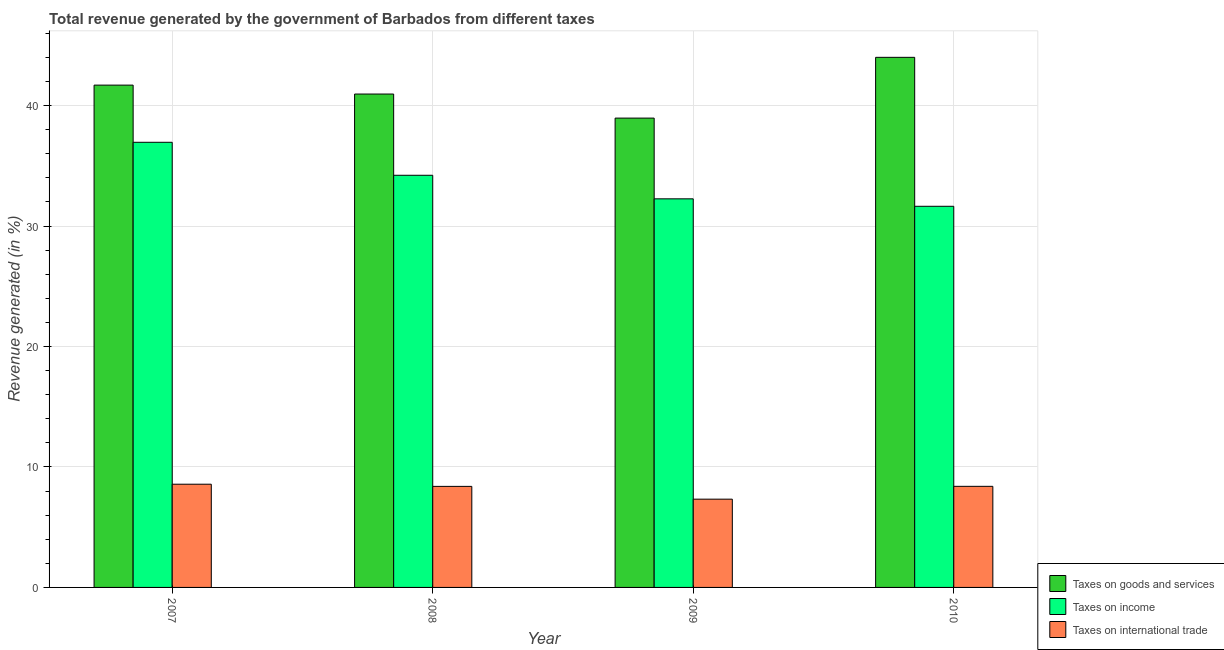How many different coloured bars are there?
Keep it short and to the point. 3. Are the number of bars per tick equal to the number of legend labels?
Provide a short and direct response. Yes. What is the label of the 3rd group of bars from the left?
Ensure brevity in your answer.  2009. In how many cases, is the number of bars for a given year not equal to the number of legend labels?
Provide a short and direct response. 0. What is the percentage of revenue generated by tax on international trade in 2008?
Your response must be concise. 8.39. Across all years, what is the maximum percentage of revenue generated by taxes on income?
Ensure brevity in your answer.  36.96. Across all years, what is the minimum percentage of revenue generated by taxes on income?
Your answer should be compact. 31.64. What is the total percentage of revenue generated by taxes on income in the graph?
Ensure brevity in your answer.  135.08. What is the difference between the percentage of revenue generated by taxes on income in 2007 and that in 2010?
Ensure brevity in your answer.  5.31. What is the difference between the percentage of revenue generated by taxes on income in 2010 and the percentage of revenue generated by tax on international trade in 2008?
Provide a short and direct response. -2.58. What is the average percentage of revenue generated by taxes on goods and services per year?
Keep it short and to the point. 41.41. In how many years, is the percentage of revenue generated by taxes on income greater than 14 %?
Provide a succinct answer. 4. What is the ratio of the percentage of revenue generated by taxes on goods and services in 2008 to that in 2009?
Make the answer very short. 1.05. Is the percentage of revenue generated by taxes on income in 2007 less than that in 2009?
Give a very brief answer. No. Is the difference between the percentage of revenue generated by taxes on income in 2008 and 2009 greater than the difference between the percentage of revenue generated by taxes on goods and services in 2008 and 2009?
Make the answer very short. No. What is the difference between the highest and the second highest percentage of revenue generated by taxes on income?
Offer a very short reply. 2.74. What is the difference between the highest and the lowest percentage of revenue generated by tax on international trade?
Your answer should be compact. 1.24. What does the 1st bar from the left in 2007 represents?
Provide a short and direct response. Taxes on goods and services. What does the 3rd bar from the right in 2009 represents?
Your answer should be compact. Taxes on goods and services. How many bars are there?
Your answer should be compact. 12. Are all the bars in the graph horizontal?
Make the answer very short. No. Does the graph contain any zero values?
Offer a terse response. No. Does the graph contain grids?
Keep it short and to the point. Yes. How are the legend labels stacked?
Make the answer very short. Vertical. What is the title of the graph?
Give a very brief answer. Total revenue generated by the government of Barbados from different taxes. What is the label or title of the X-axis?
Your response must be concise. Year. What is the label or title of the Y-axis?
Provide a short and direct response. Revenue generated (in %). What is the Revenue generated (in %) of Taxes on goods and services in 2007?
Offer a terse response. 41.7. What is the Revenue generated (in %) in Taxes on income in 2007?
Your response must be concise. 36.96. What is the Revenue generated (in %) in Taxes on international trade in 2007?
Offer a terse response. 8.57. What is the Revenue generated (in %) in Taxes on goods and services in 2008?
Provide a succinct answer. 40.96. What is the Revenue generated (in %) in Taxes on income in 2008?
Ensure brevity in your answer.  34.22. What is the Revenue generated (in %) in Taxes on international trade in 2008?
Your answer should be very brief. 8.39. What is the Revenue generated (in %) in Taxes on goods and services in 2009?
Ensure brevity in your answer.  38.97. What is the Revenue generated (in %) of Taxes on income in 2009?
Ensure brevity in your answer.  32.26. What is the Revenue generated (in %) of Taxes on international trade in 2009?
Make the answer very short. 7.33. What is the Revenue generated (in %) in Taxes on goods and services in 2010?
Your response must be concise. 44.01. What is the Revenue generated (in %) in Taxes on income in 2010?
Keep it short and to the point. 31.64. What is the Revenue generated (in %) of Taxes on international trade in 2010?
Provide a succinct answer. 8.39. Across all years, what is the maximum Revenue generated (in %) in Taxes on goods and services?
Provide a short and direct response. 44.01. Across all years, what is the maximum Revenue generated (in %) of Taxes on income?
Ensure brevity in your answer.  36.96. Across all years, what is the maximum Revenue generated (in %) of Taxes on international trade?
Provide a short and direct response. 8.57. Across all years, what is the minimum Revenue generated (in %) of Taxes on goods and services?
Make the answer very short. 38.97. Across all years, what is the minimum Revenue generated (in %) of Taxes on income?
Make the answer very short. 31.64. Across all years, what is the minimum Revenue generated (in %) of Taxes on international trade?
Your response must be concise. 7.33. What is the total Revenue generated (in %) in Taxes on goods and services in the graph?
Give a very brief answer. 165.64. What is the total Revenue generated (in %) in Taxes on income in the graph?
Give a very brief answer. 135.08. What is the total Revenue generated (in %) of Taxes on international trade in the graph?
Ensure brevity in your answer.  32.68. What is the difference between the Revenue generated (in %) in Taxes on goods and services in 2007 and that in 2008?
Offer a terse response. 0.74. What is the difference between the Revenue generated (in %) in Taxes on income in 2007 and that in 2008?
Ensure brevity in your answer.  2.74. What is the difference between the Revenue generated (in %) of Taxes on international trade in 2007 and that in 2008?
Your answer should be very brief. 0.18. What is the difference between the Revenue generated (in %) in Taxes on goods and services in 2007 and that in 2009?
Your answer should be compact. 2.74. What is the difference between the Revenue generated (in %) in Taxes on income in 2007 and that in 2009?
Give a very brief answer. 4.69. What is the difference between the Revenue generated (in %) of Taxes on international trade in 2007 and that in 2009?
Provide a short and direct response. 1.24. What is the difference between the Revenue generated (in %) in Taxes on goods and services in 2007 and that in 2010?
Offer a very short reply. -2.31. What is the difference between the Revenue generated (in %) in Taxes on income in 2007 and that in 2010?
Give a very brief answer. 5.31. What is the difference between the Revenue generated (in %) of Taxes on international trade in 2007 and that in 2010?
Make the answer very short. 0.18. What is the difference between the Revenue generated (in %) in Taxes on goods and services in 2008 and that in 2009?
Provide a succinct answer. 2. What is the difference between the Revenue generated (in %) in Taxes on income in 2008 and that in 2009?
Your answer should be compact. 1.96. What is the difference between the Revenue generated (in %) of Taxes on international trade in 2008 and that in 2009?
Make the answer very short. 1.06. What is the difference between the Revenue generated (in %) of Taxes on goods and services in 2008 and that in 2010?
Keep it short and to the point. -3.05. What is the difference between the Revenue generated (in %) in Taxes on income in 2008 and that in 2010?
Provide a short and direct response. 2.58. What is the difference between the Revenue generated (in %) of Taxes on international trade in 2008 and that in 2010?
Your answer should be compact. -0. What is the difference between the Revenue generated (in %) of Taxes on goods and services in 2009 and that in 2010?
Offer a terse response. -5.04. What is the difference between the Revenue generated (in %) in Taxes on income in 2009 and that in 2010?
Offer a terse response. 0.62. What is the difference between the Revenue generated (in %) in Taxes on international trade in 2009 and that in 2010?
Your answer should be compact. -1.06. What is the difference between the Revenue generated (in %) in Taxes on goods and services in 2007 and the Revenue generated (in %) in Taxes on income in 2008?
Your response must be concise. 7.48. What is the difference between the Revenue generated (in %) in Taxes on goods and services in 2007 and the Revenue generated (in %) in Taxes on international trade in 2008?
Ensure brevity in your answer.  33.31. What is the difference between the Revenue generated (in %) of Taxes on income in 2007 and the Revenue generated (in %) of Taxes on international trade in 2008?
Ensure brevity in your answer.  28.57. What is the difference between the Revenue generated (in %) of Taxes on goods and services in 2007 and the Revenue generated (in %) of Taxes on income in 2009?
Your response must be concise. 9.44. What is the difference between the Revenue generated (in %) in Taxes on goods and services in 2007 and the Revenue generated (in %) in Taxes on international trade in 2009?
Give a very brief answer. 34.37. What is the difference between the Revenue generated (in %) in Taxes on income in 2007 and the Revenue generated (in %) in Taxes on international trade in 2009?
Provide a short and direct response. 29.63. What is the difference between the Revenue generated (in %) in Taxes on goods and services in 2007 and the Revenue generated (in %) in Taxes on income in 2010?
Provide a succinct answer. 10.06. What is the difference between the Revenue generated (in %) of Taxes on goods and services in 2007 and the Revenue generated (in %) of Taxes on international trade in 2010?
Keep it short and to the point. 33.31. What is the difference between the Revenue generated (in %) in Taxes on income in 2007 and the Revenue generated (in %) in Taxes on international trade in 2010?
Your response must be concise. 28.56. What is the difference between the Revenue generated (in %) in Taxes on goods and services in 2008 and the Revenue generated (in %) in Taxes on income in 2009?
Offer a very short reply. 8.7. What is the difference between the Revenue generated (in %) in Taxes on goods and services in 2008 and the Revenue generated (in %) in Taxes on international trade in 2009?
Offer a very short reply. 33.63. What is the difference between the Revenue generated (in %) in Taxes on income in 2008 and the Revenue generated (in %) in Taxes on international trade in 2009?
Offer a terse response. 26.89. What is the difference between the Revenue generated (in %) of Taxes on goods and services in 2008 and the Revenue generated (in %) of Taxes on income in 2010?
Your answer should be compact. 9.32. What is the difference between the Revenue generated (in %) of Taxes on goods and services in 2008 and the Revenue generated (in %) of Taxes on international trade in 2010?
Ensure brevity in your answer.  32.57. What is the difference between the Revenue generated (in %) in Taxes on income in 2008 and the Revenue generated (in %) in Taxes on international trade in 2010?
Give a very brief answer. 25.83. What is the difference between the Revenue generated (in %) in Taxes on goods and services in 2009 and the Revenue generated (in %) in Taxes on income in 2010?
Keep it short and to the point. 7.32. What is the difference between the Revenue generated (in %) of Taxes on goods and services in 2009 and the Revenue generated (in %) of Taxes on international trade in 2010?
Keep it short and to the point. 30.57. What is the difference between the Revenue generated (in %) in Taxes on income in 2009 and the Revenue generated (in %) in Taxes on international trade in 2010?
Your answer should be very brief. 23.87. What is the average Revenue generated (in %) of Taxes on goods and services per year?
Your response must be concise. 41.41. What is the average Revenue generated (in %) in Taxes on income per year?
Give a very brief answer. 33.77. What is the average Revenue generated (in %) in Taxes on international trade per year?
Offer a terse response. 8.17. In the year 2007, what is the difference between the Revenue generated (in %) of Taxes on goods and services and Revenue generated (in %) of Taxes on income?
Give a very brief answer. 4.75. In the year 2007, what is the difference between the Revenue generated (in %) of Taxes on goods and services and Revenue generated (in %) of Taxes on international trade?
Keep it short and to the point. 33.13. In the year 2007, what is the difference between the Revenue generated (in %) in Taxes on income and Revenue generated (in %) in Taxes on international trade?
Your response must be concise. 28.39. In the year 2008, what is the difference between the Revenue generated (in %) in Taxes on goods and services and Revenue generated (in %) in Taxes on income?
Make the answer very short. 6.74. In the year 2008, what is the difference between the Revenue generated (in %) of Taxes on goods and services and Revenue generated (in %) of Taxes on international trade?
Ensure brevity in your answer.  32.57. In the year 2008, what is the difference between the Revenue generated (in %) of Taxes on income and Revenue generated (in %) of Taxes on international trade?
Ensure brevity in your answer.  25.83. In the year 2009, what is the difference between the Revenue generated (in %) in Taxes on goods and services and Revenue generated (in %) in Taxes on income?
Make the answer very short. 6.7. In the year 2009, what is the difference between the Revenue generated (in %) in Taxes on goods and services and Revenue generated (in %) in Taxes on international trade?
Offer a very short reply. 31.64. In the year 2009, what is the difference between the Revenue generated (in %) of Taxes on income and Revenue generated (in %) of Taxes on international trade?
Offer a very short reply. 24.93. In the year 2010, what is the difference between the Revenue generated (in %) in Taxes on goods and services and Revenue generated (in %) in Taxes on income?
Give a very brief answer. 12.37. In the year 2010, what is the difference between the Revenue generated (in %) in Taxes on goods and services and Revenue generated (in %) in Taxes on international trade?
Make the answer very short. 35.62. In the year 2010, what is the difference between the Revenue generated (in %) in Taxes on income and Revenue generated (in %) in Taxes on international trade?
Your answer should be compact. 23.25. What is the ratio of the Revenue generated (in %) of Taxes on goods and services in 2007 to that in 2008?
Ensure brevity in your answer.  1.02. What is the ratio of the Revenue generated (in %) in Taxes on international trade in 2007 to that in 2008?
Your response must be concise. 1.02. What is the ratio of the Revenue generated (in %) of Taxes on goods and services in 2007 to that in 2009?
Your answer should be very brief. 1.07. What is the ratio of the Revenue generated (in %) in Taxes on income in 2007 to that in 2009?
Offer a terse response. 1.15. What is the ratio of the Revenue generated (in %) of Taxes on international trade in 2007 to that in 2009?
Provide a short and direct response. 1.17. What is the ratio of the Revenue generated (in %) in Taxes on goods and services in 2007 to that in 2010?
Offer a very short reply. 0.95. What is the ratio of the Revenue generated (in %) of Taxes on income in 2007 to that in 2010?
Make the answer very short. 1.17. What is the ratio of the Revenue generated (in %) in Taxes on international trade in 2007 to that in 2010?
Your answer should be compact. 1.02. What is the ratio of the Revenue generated (in %) of Taxes on goods and services in 2008 to that in 2009?
Provide a succinct answer. 1.05. What is the ratio of the Revenue generated (in %) of Taxes on income in 2008 to that in 2009?
Your answer should be compact. 1.06. What is the ratio of the Revenue generated (in %) in Taxes on international trade in 2008 to that in 2009?
Provide a succinct answer. 1.14. What is the ratio of the Revenue generated (in %) in Taxes on goods and services in 2008 to that in 2010?
Make the answer very short. 0.93. What is the ratio of the Revenue generated (in %) in Taxes on income in 2008 to that in 2010?
Keep it short and to the point. 1.08. What is the ratio of the Revenue generated (in %) in Taxes on goods and services in 2009 to that in 2010?
Offer a terse response. 0.89. What is the ratio of the Revenue generated (in %) of Taxes on income in 2009 to that in 2010?
Ensure brevity in your answer.  1.02. What is the ratio of the Revenue generated (in %) of Taxes on international trade in 2009 to that in 2010?
Your response must be concise. 0.87. What is the difference between the highest and the second highest Revenue generated (in %) in Taxes on goods and services?
Make the answer very short. 2.31. What is the difference between the highest and the second highest Revenue generated (in %) in Taxes on income?
Offer a very short reply. 2.74. What is the difference between the highest and the second highest Revenue generated (in %) of Taxes on international trade?
Your response must be concise. 0.18. What is the difference between the highest and the lowest Revenue generated (in %) in Taxes on goods and services?
Give a very brief answer. 5.04. What is the difference between the highest and the lowest Revenue generated (in %) in Taxes on income?
Give a very brief answer. 5.31. What is the difference between the highest and the lowest Revenue generated (in %) of Taxes on international trade?
Give a very brief answer. 1.24. 